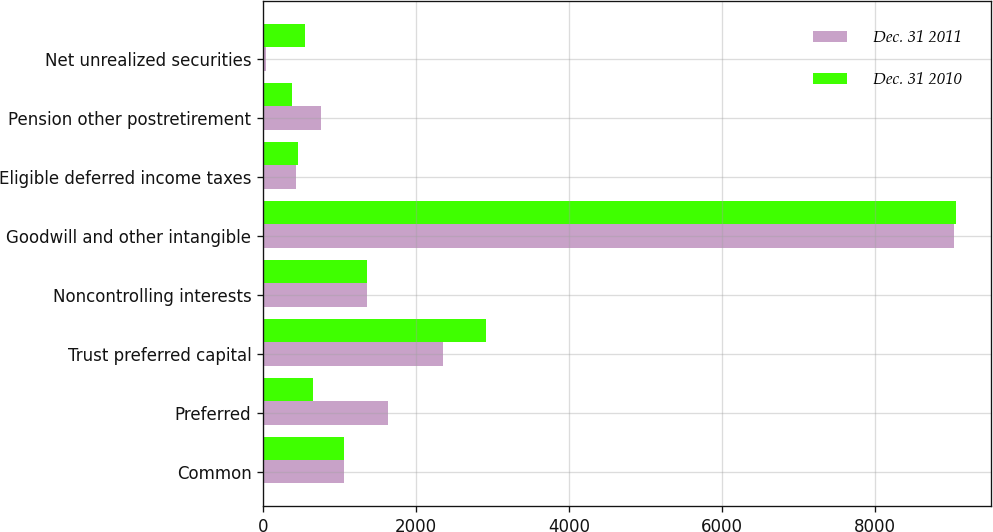<chart> <loc_0><loc_0><loc_500><loc_500><stacked_bar_chart><ecel><fcel>Common<fcel>Preferred<fcel>Trust preferred capital<fcel>Noncontrolling interests<fcel>Goodwill and other intangible<fcel>Eligible deferred income taxes<fcel>Pension other postretirement<fcel>Net unrealized securities<nl><fcel>Dec. 31 2011<fcel>1053<fcel>1636<fcel>2354<fcel>1351<fcel>9027<fcel>431<fcel>755<fcel>41<nl><fcel>Dec. 31 2010<fcel>1053<fcel>646<fcel>2907<fcel>1351<fcel>9053<fcel>461<fcel>380<fcel>550<nl></chart> 